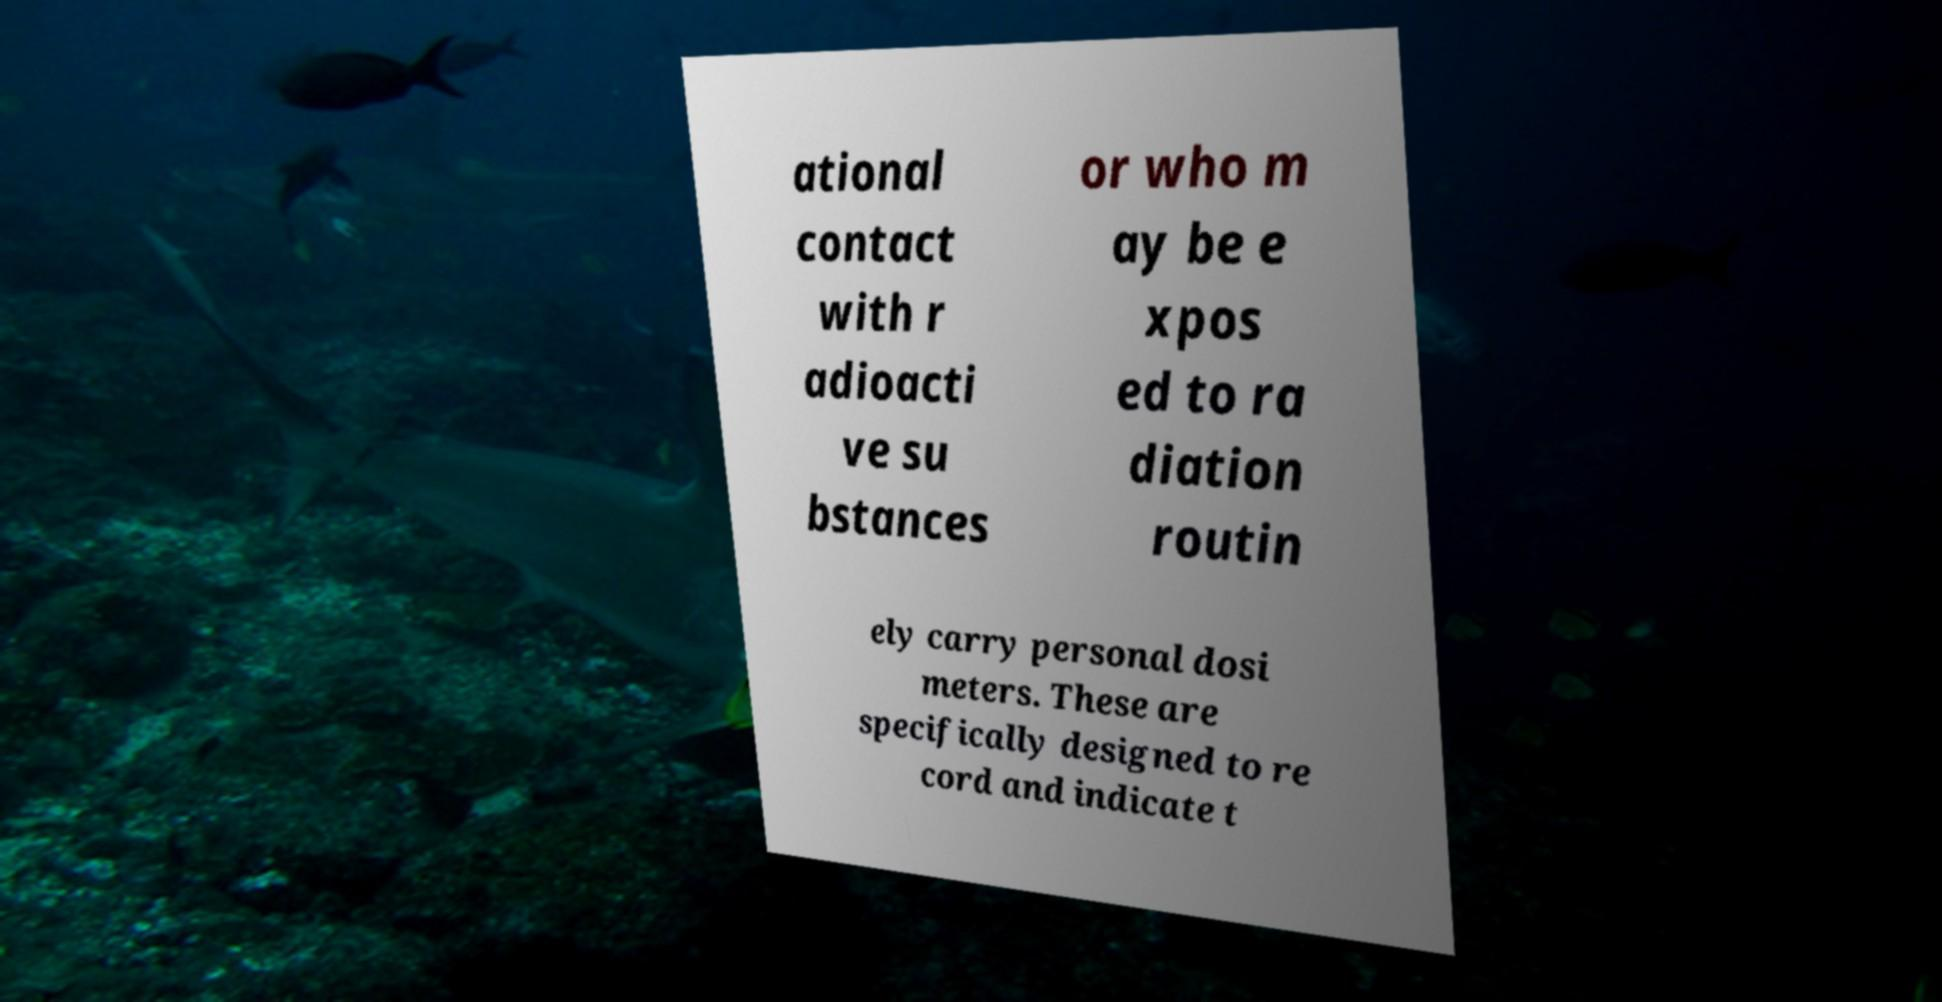I need the written content from this picture converted into text. Can you do that? ational contact with r adioacti ve su bstances or who m ay be e xpos ed to ra diation routin ely carry personal dosi meters. These are specifically designed to re cord and indicate t 